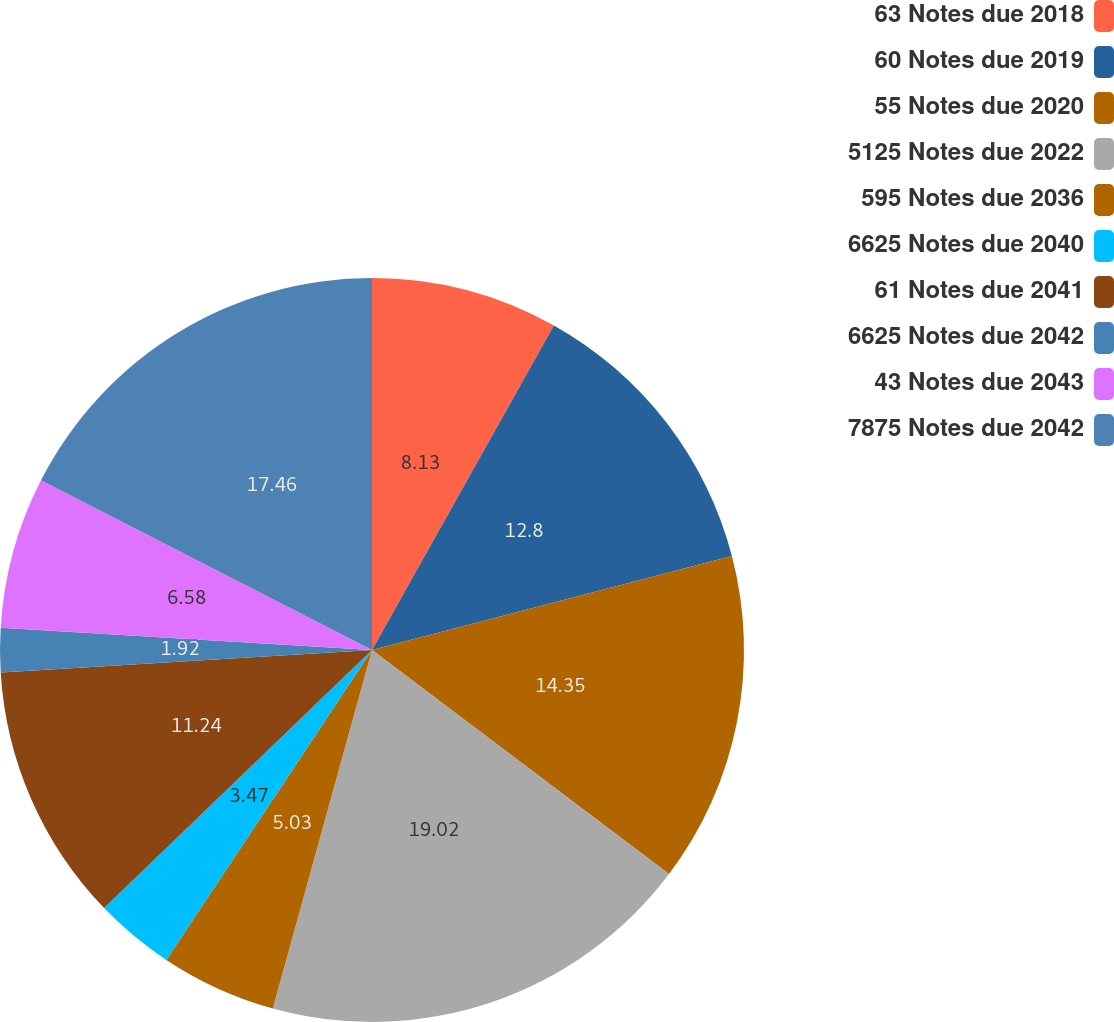Convert chart to OTSL. <chart><loc_0><loc_0><loc_500><loc_500><pie_chart><fcel>63 Notes due 2018<fcel>60 Notes due 2019<fcel>55 Notes due 2020<fcel>5125 Notes due 2022<fcel>595 Notes due 2036<fcel>6625 Notes due 2040<fcel>61 Notes due 2041<fcel>6625 Notes due 2042<fcel>43 Notes due 2043<fcel>7875 Notes due 2042<nl><fcel>8.13%<fcel>12.8%<fcel>14.35%<fcel>19.01%<fcel>5.03%<fcel>3.47%<fcel>11.24%<fcel>1.92%<fcel>6.58%<fcel>17.46%<nl></chart> 